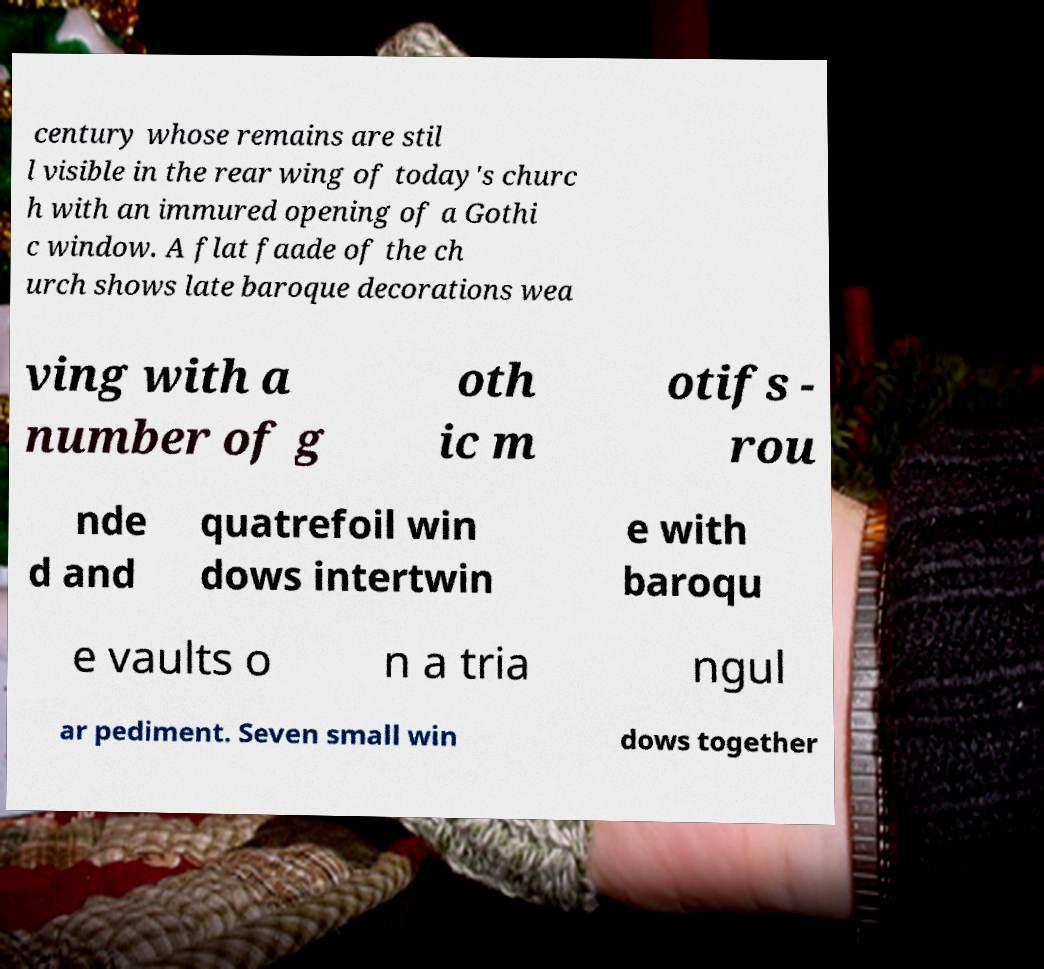Please read and relay the text visible in this image. What does it say? century whose remains are stil l visible in the rear wing of today's churc h with an immured opening of a Gothi c window. A flat faade of the ch urch shows late baroque decorations wea ving with a number of g oth ic m otifs - rou nde d and quatrefoil win dows intertwin e with baroqu e vaults o n a tria ngul ar pediment. Seven small win dows together 